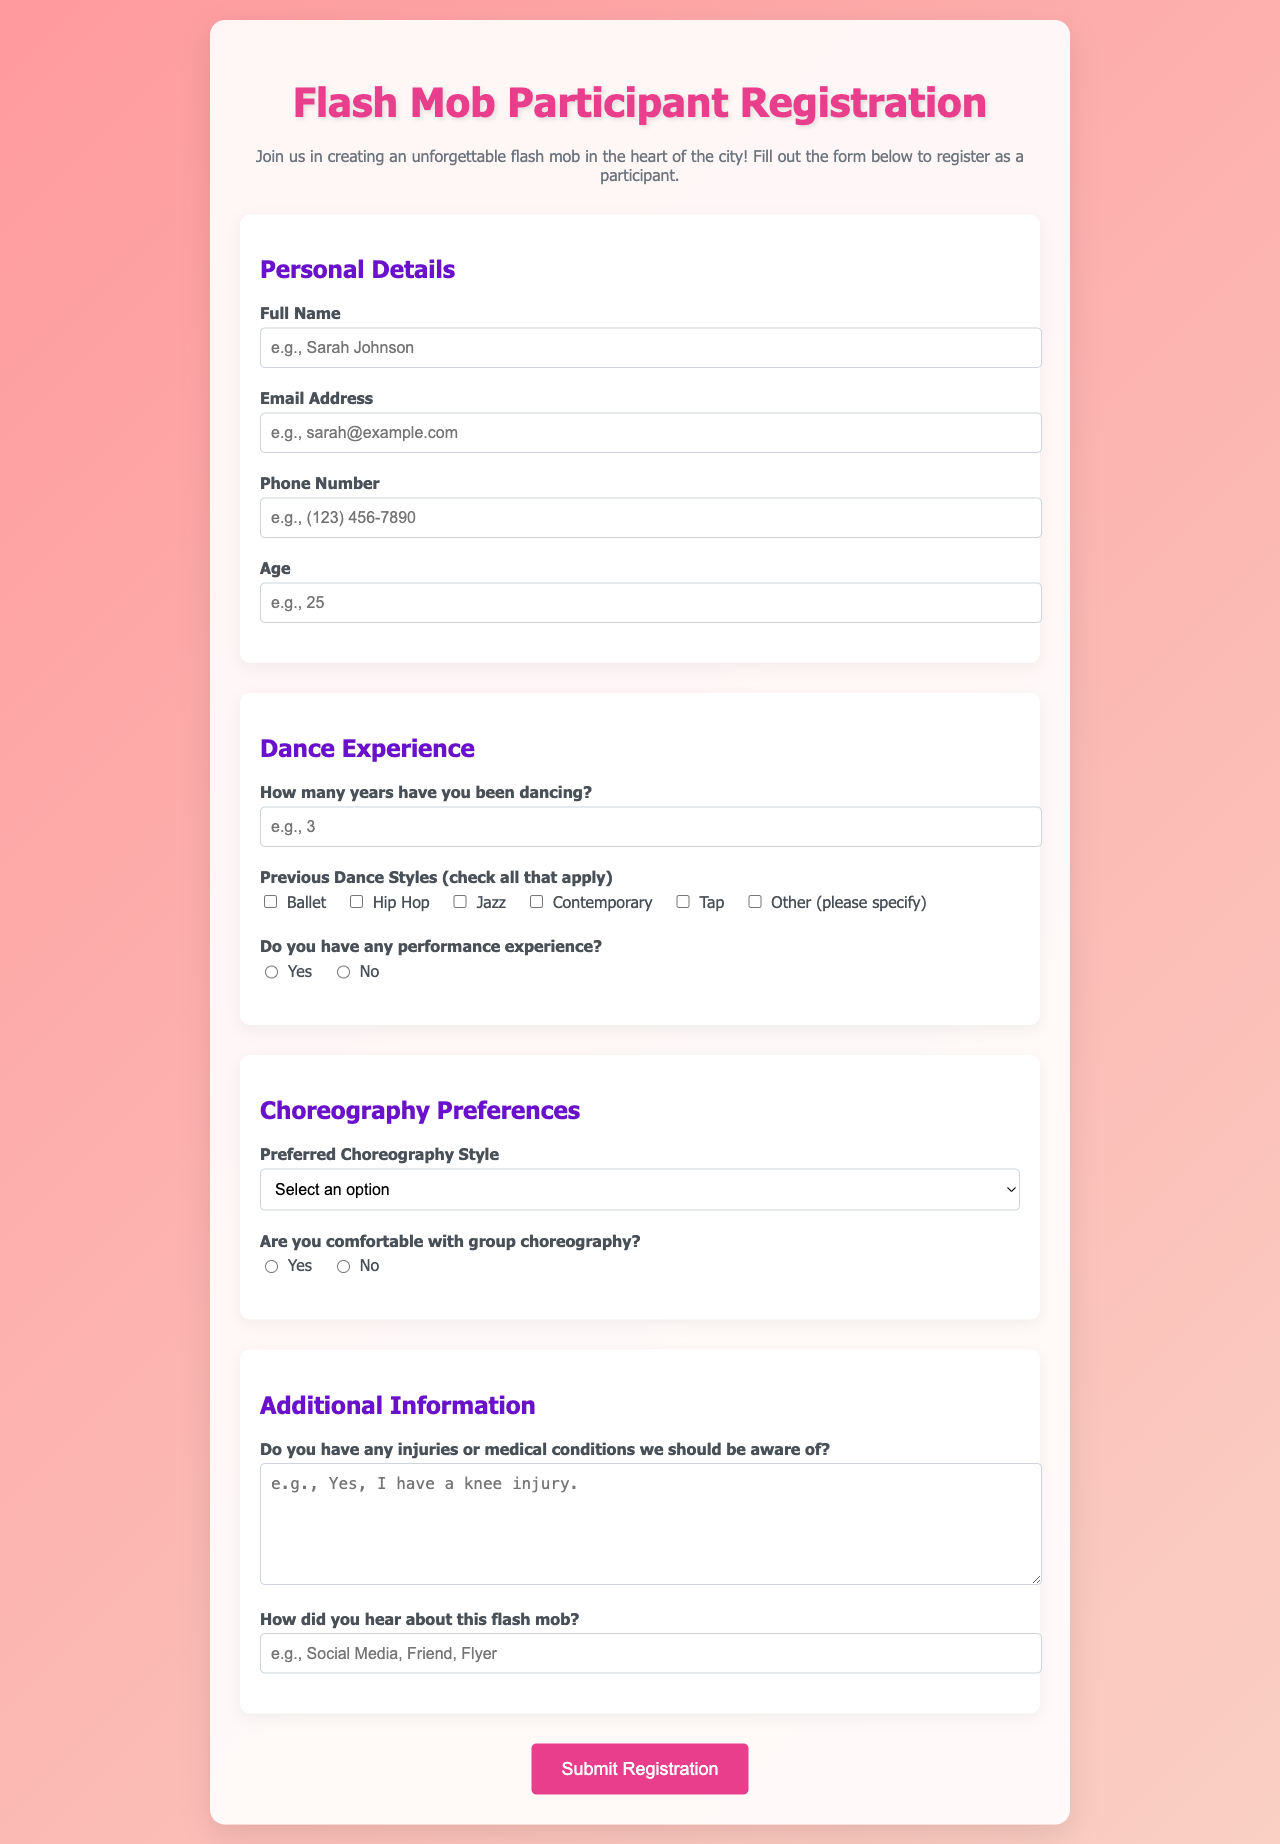What is the title of the document? The title of the document is displayed prominently at the top of the page in a large font.
Answer: Flash Mob Participant Registration What is the minimum age to register? The minimum age for registration is specified in the age input field, outlining the accepted range.
Answer: 10 Which social media platform can be a source of information about the flash mob? A potential source of how participants heard about the flash mob is provided in the input field labeled "How did you hear about this flash mob?".
Answer: Social Media What are the preferred choreography styles listed? The document provides a dropdown menu containing options for choreography styles that participants can select.
Answer: High Energy, Slow and Graceful, Themed, Pop Music-Inspired, Other How many years of dance experience is required? There is no specific requirement mentioned for the minimum number of years of dance experience; however, participants are asked to provide the number of years in the corresponding input field.
Answer: 0 (minimum) Is there a question asking for previous dance styles? The form has a section where participants can select multiple previous dance styles they have experience in, thus answering this question.
Answer: Yes What color is the background gradient of the document? The color scheme of the document's background is defined by the gradient specified in the style section of the document.
Answer: Pink Is there a section for sharing medical conditions? The form includes a specific area for participants to disclose any medical conditions or injuries that should be considered, fulfilling this need.
Answer: Yes 